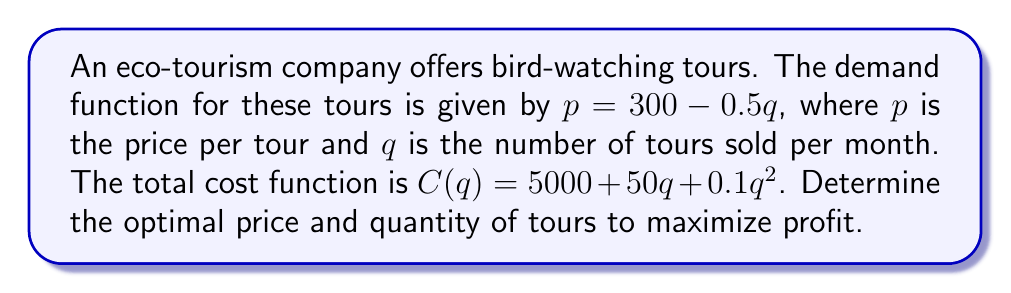Could you help me with this problem? 1. First, we need to formulate the profit function:
   Profit = Revenue - Cost
   $\pi(q) = pq - C(q)$

2. Substitute the demand function into the profit function:
   $\pi(q) = (300 - 0.5q)q - (5000 + 50q + 0.1q^2)$
   $\pi(q) = 300q - 0.5q^2 - 5000 - 50q - 0.1q^2$
   $\pi(q) = -0.6q^2 + 250q - 5000$

3. To maximize profit, we need to find the derivative of the profit function and set it equal to zero:
   $\frac{d\pi}{dq} = -1.2q + 250 = 0$

4. Solve for q:
   $-1.2q = -250$
   $q = \frac{250}{1.2} \approx 208.33$

5. Since we can't sell fractional tours, we round down to 208 tours per month.

6. To find the optimal price, substitute q = 208 into the demand function:
   $p = 300 - 0.5(208) = 196$

7. Verify that the second derivative is negative to confirm this is a maximum:
   $\frac{d^2\pi}{dq^2} = -1.2 < 0$, so this is indeed a maximum.
Answer: Optimal price: $196 per tour; Optimal quantity: 208 tours per month 